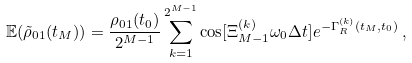Convert formula to latex. <formula><loc_0><loc_0><loc_500><loc_500>\mathbb { E } ( \tilde { \rho } _ { 0 1 } ( t _ { M } ) ) = \frac { \rho _ { 0 1 } ( t _ { 0 } ) } { 2 ^ { M - 1 } } \sum _ { k = 1 } ^ { 2 ^ { M - 1 } } \cos [ \Xi _ { M - 1 } ^ { ( k ) } \omega _ { 0 } \Delta t ] e ^ { - \Gamma _ { R } ^ { ( k ) } ( t _ { M } , t _ { 0 } ) } \, ,</formula> 